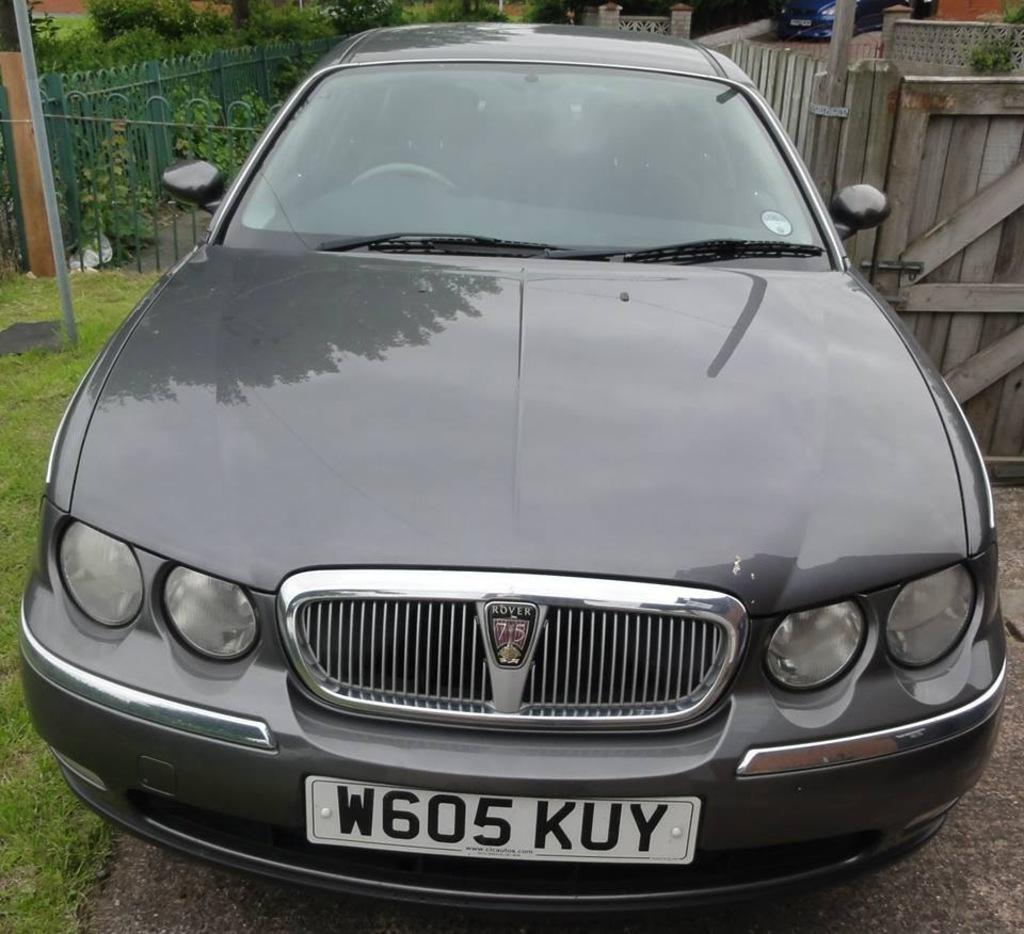<image>
Present a compact description of the photo's key features. A charcoal Rover sits on a driveway in front of a garden. 